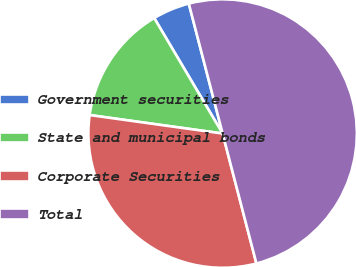Convert chart. <chart><loc_0><loc_0><loc_500><loc_500><pie_chart><fcel>Government securities<fcel>State and municipal bonds<fcel>Corporate Securities<fcel>Total<nl><fcel>4.46%<fcel>14.29%<fcel>31.25%<fcel>50.0%<nl></chart> 